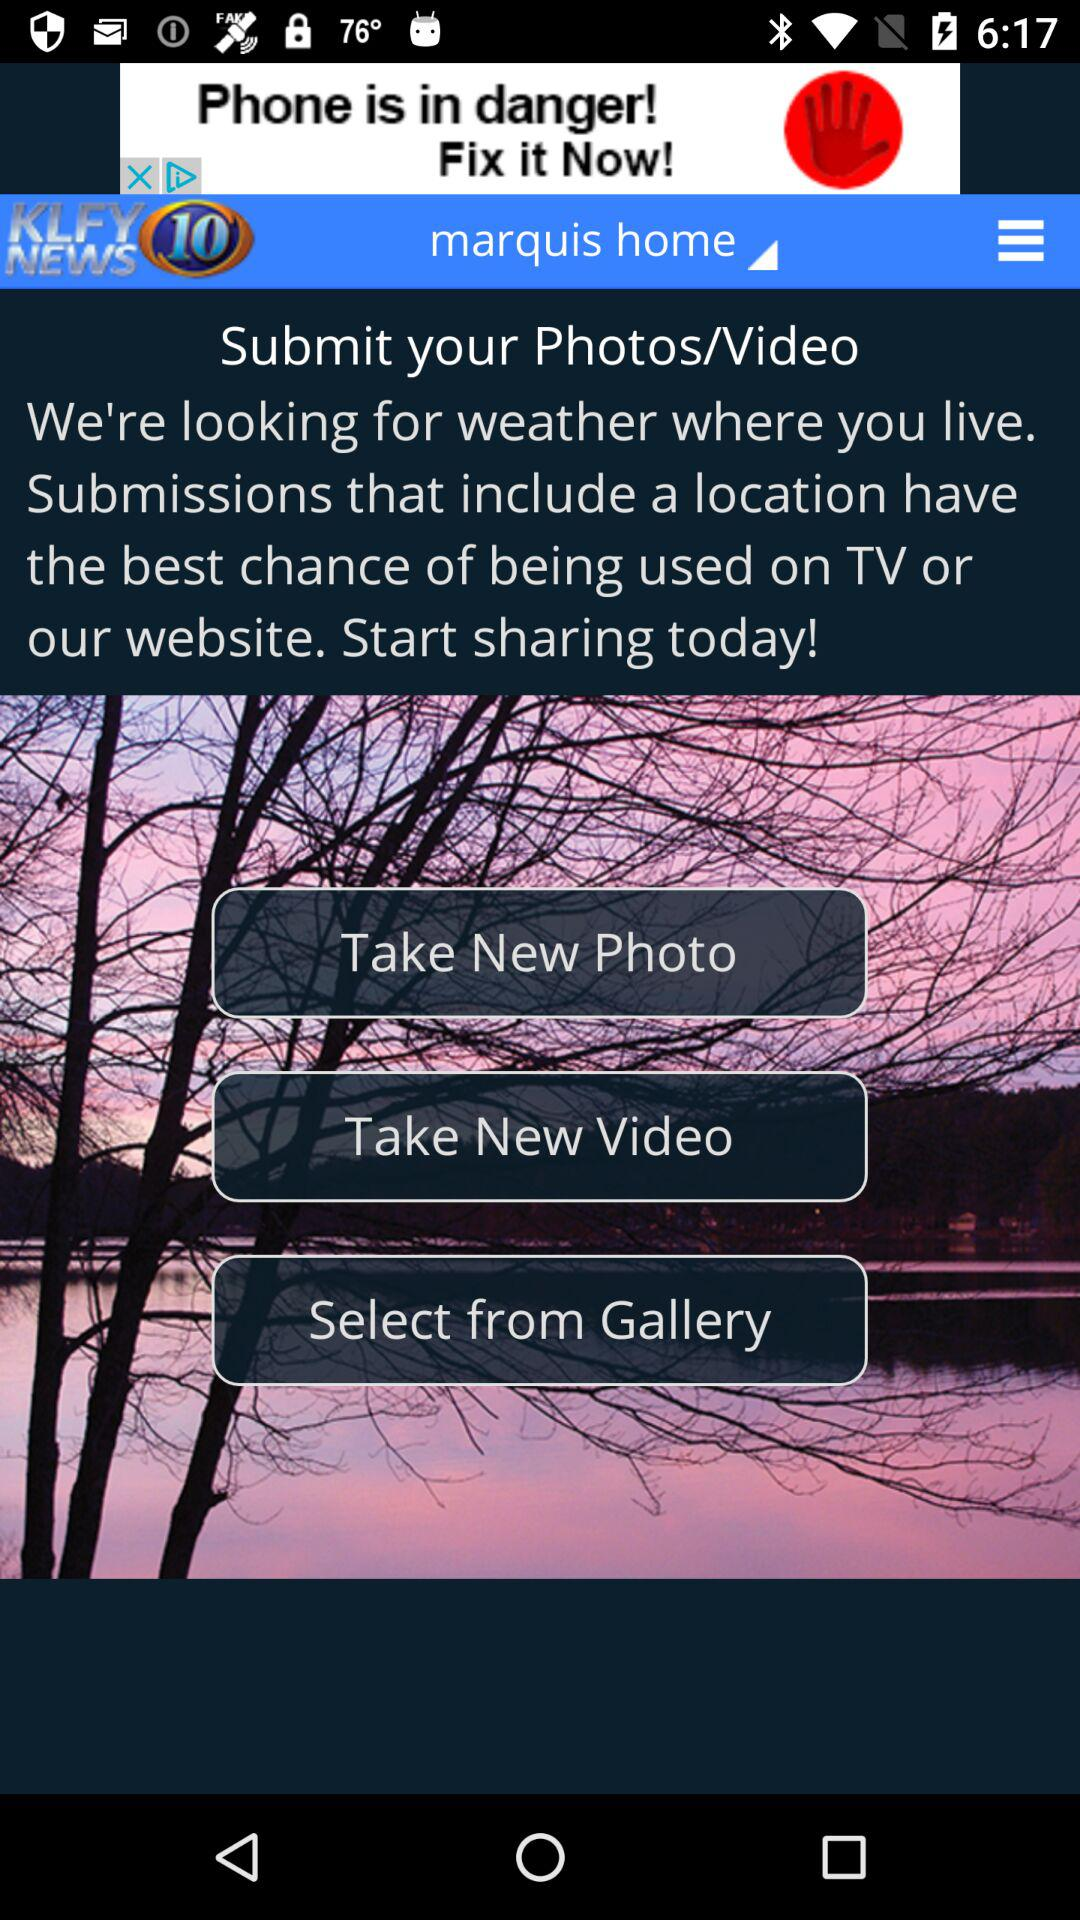What is the television station name? The television station name is "KLFY NEWS 10". 